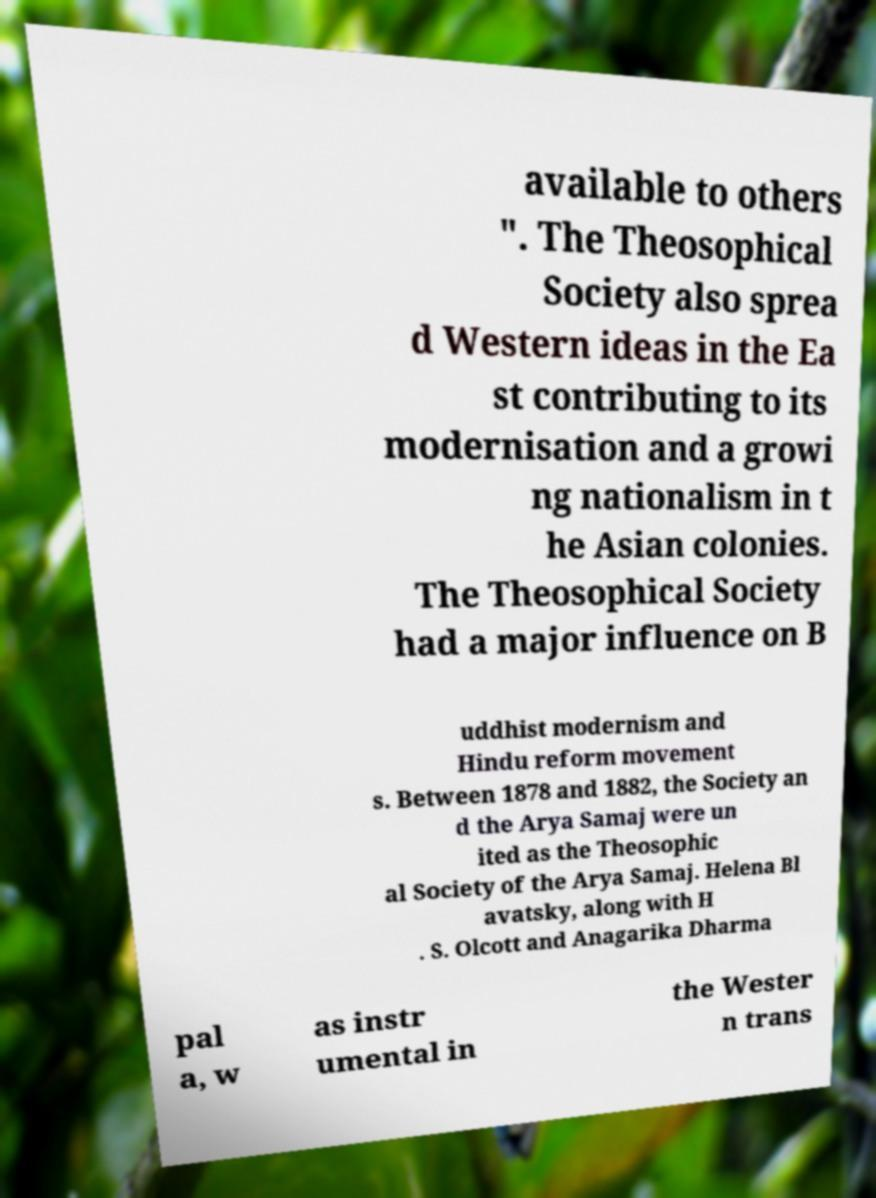Can you accurately transcribe the text from the provided image for me? available to others ". The Theosophical Society also sprea d Western ideas in the Ea st contributing to its modernisation and a growi ng nationalism in t he Asian colonies. The Theosophical Society had a major influence on B uddhist modernism and Hindu reform movement s. Between 1878 and 1882, the Society an d the Arya Samaj were un ited as the Theosophic al Society of the Arya Samaj. Helena Bl avatsky, along with H . S. Olcott and Anagarika Dharma pal a, w as instr umental in the Wester n trans 